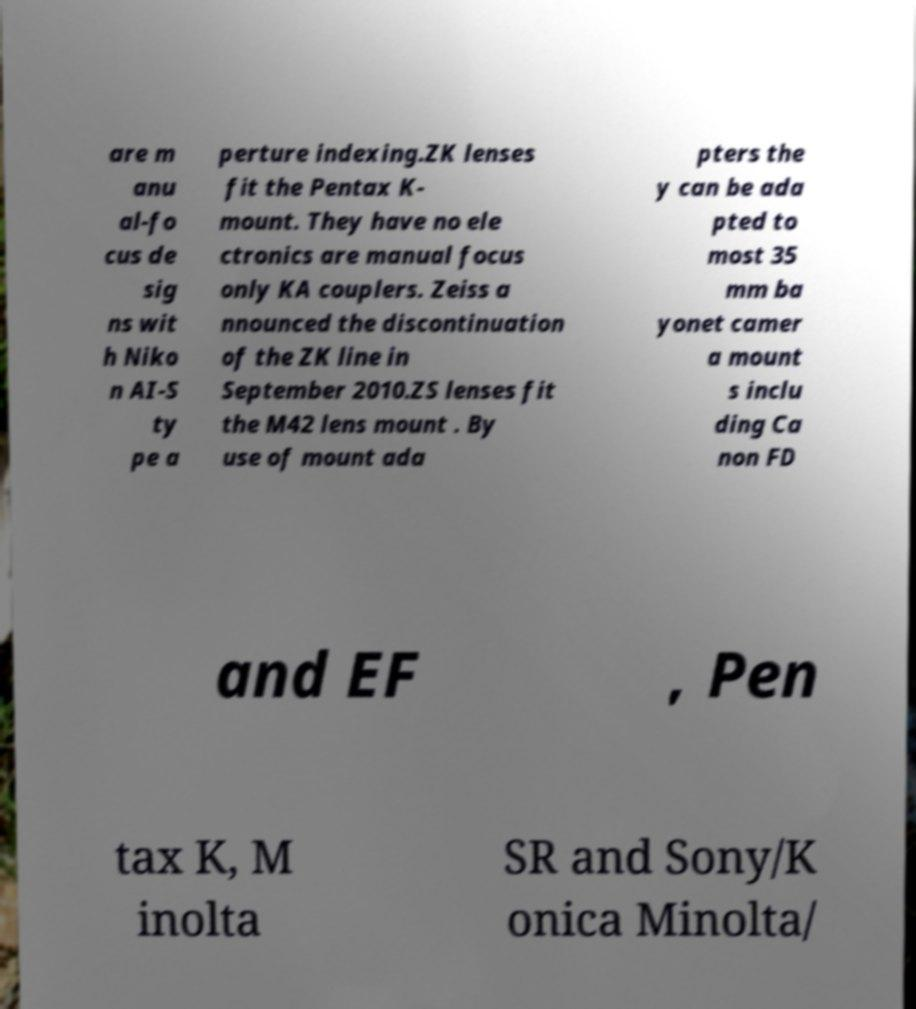Can you accurately transcribe the text from the provided image for me? are m anu al-fo cus de sig ns wit h Niko n AI-S ty pe a perture indexing.ZK lenses fit the Pentax K- mount. They have no ele ctronics are manual focus only KA couplers. Zeiss a nnounced the discontinuation of the ZK line in September 2010.ZS lenses fit the M42 lens mount . By use of mount ada pters the y can be ada pted to most 35 mm ba yonet camer a mount s inclu ding Ca non FD and EF , Pen tax K, M inolta SR and Sony/K onica Minolta/ 